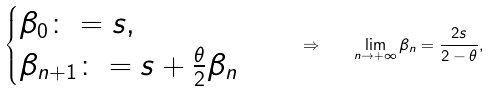<formula> <loc_0><loc_0><loc_500><loc_500>\begin{cases} \beta _ { 0 } \colon = s , \\ \beta _ { n + 1 } \colon = s + \frac { \theta } { 2 } \beta _ { n } \end{cases} \quad \Rightarrow \quad \lim _ { n \to + \infty } \beta _ { n } = \frac { 2 s } { 2 - \theta } ,</formula> 